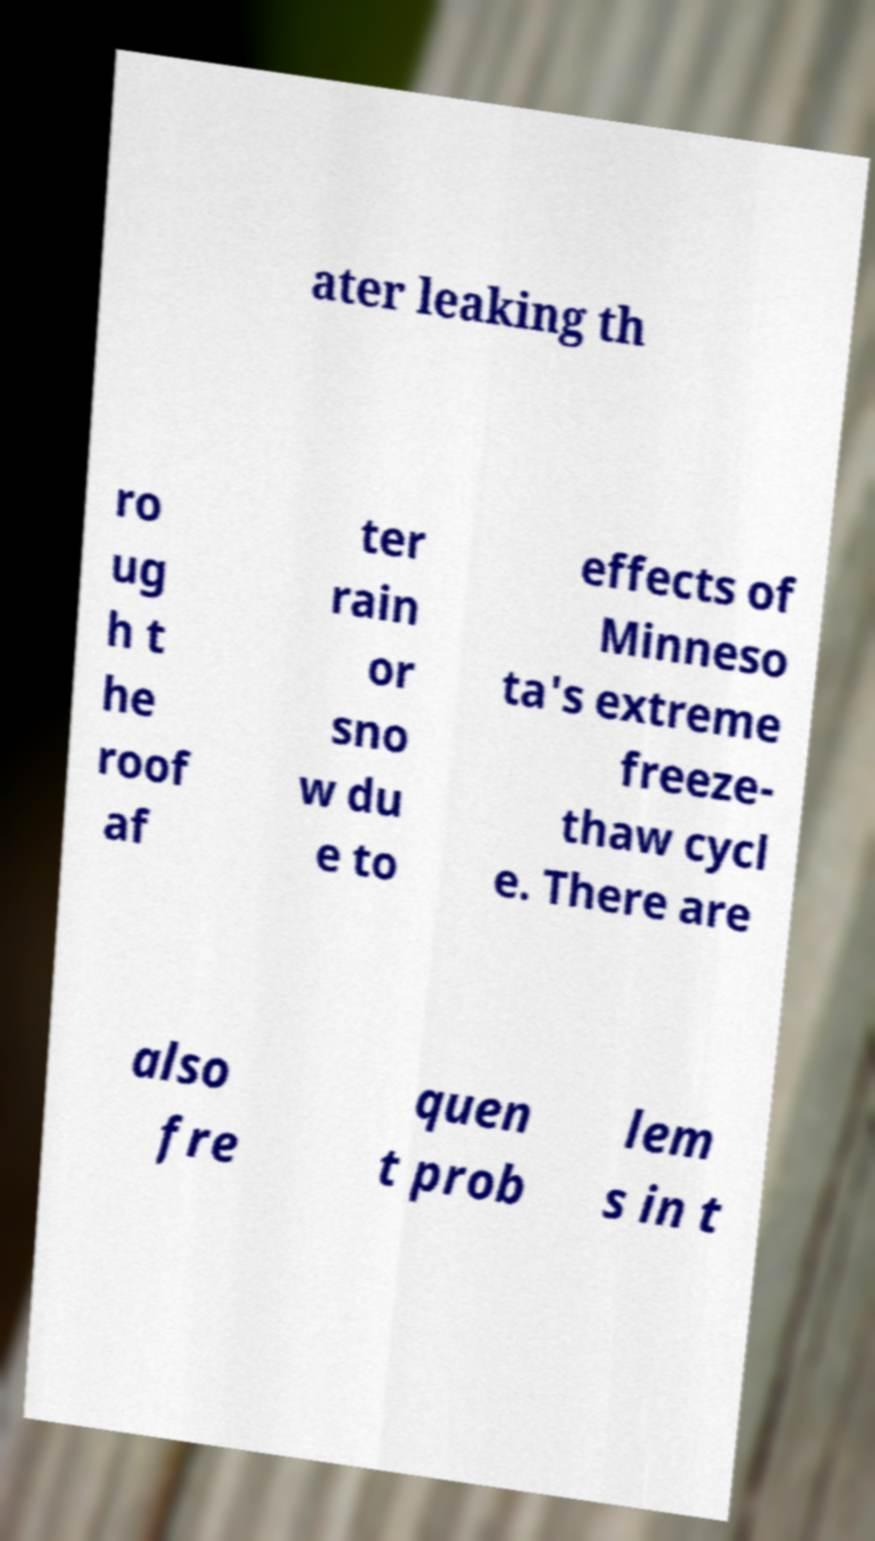Please read and relay the text visible in this image. What does it say? ater leaking th ro ug h t he roof af ter rain or sno w du e to effects of Minneso ta's extreme freeze- thaw cycl e. There are also fre quen t prob lem s in t 